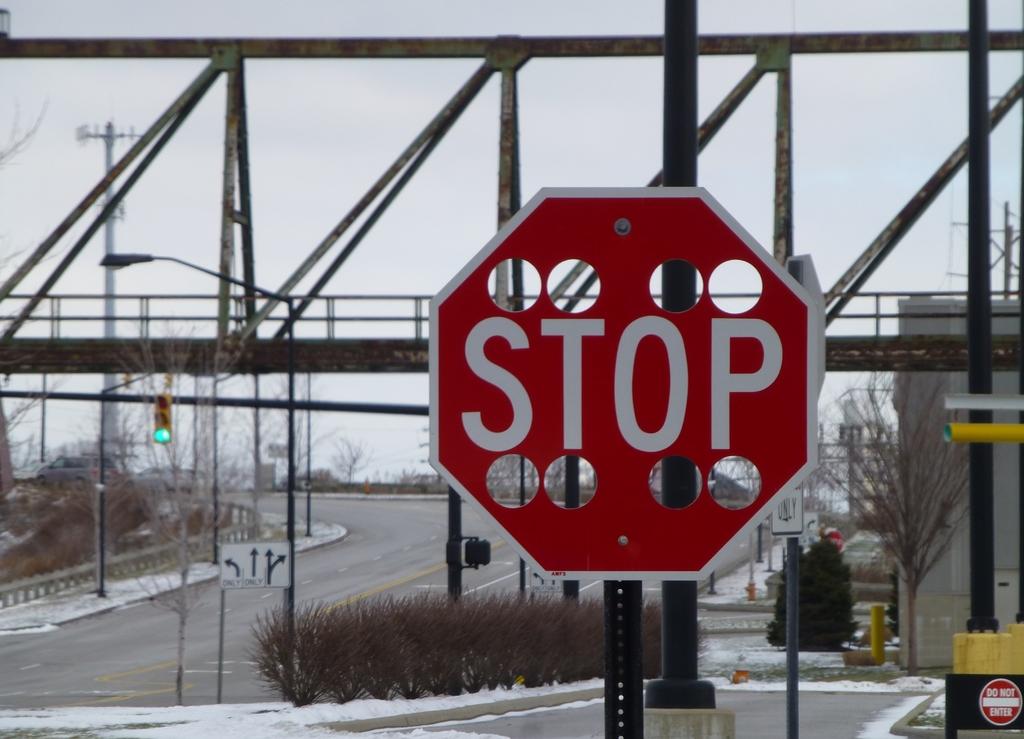What is the sign telling us to do?
Your response must be concise. Stop. What is the sign on the bottom right?
Keep it short and to the point. Do not enter. 